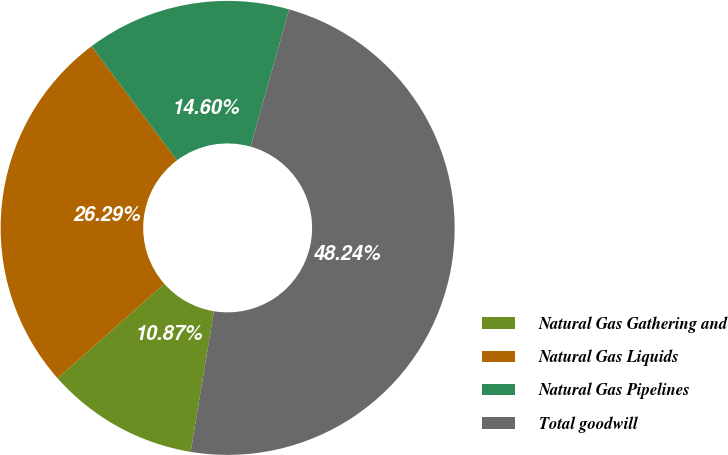Convert chart. <chart><loc_0><loc_0><loc_500><loc_500><pie_chart><fcel>Natural Gas Gathering and<fcel>Natural Gas Liquids<fcel>Natural Gas Pipelines<fcel>Total goodwill<nl><fcel>10.87%<fcel>26.29%<fcel>14.6%<fcel>48.24%<nl></chart> 